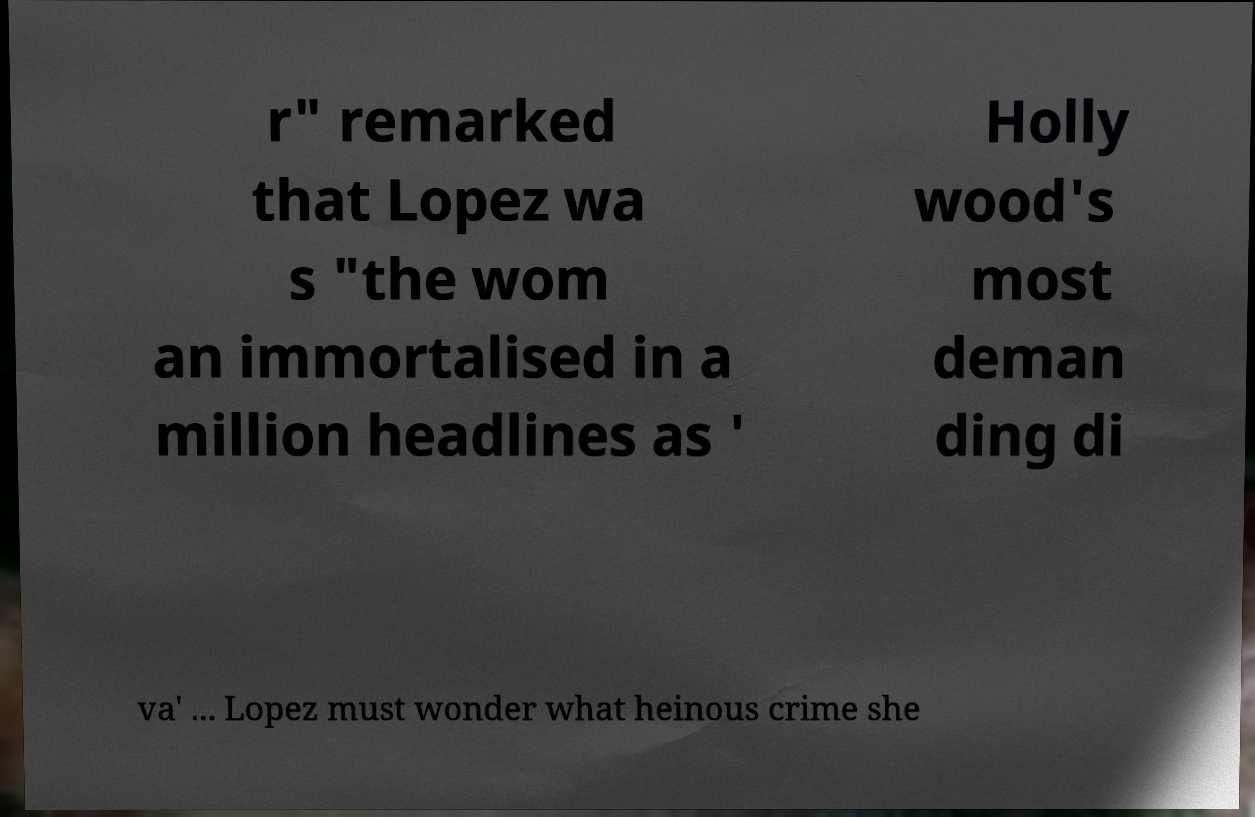Please read and relay the text visible in this image. What does it say? r" remarked that Lopez wa s "the wom an immortalised in a million headlines as ' Holly wood's most deman ding di va' ... Lopez must wonder what heinous crime she 